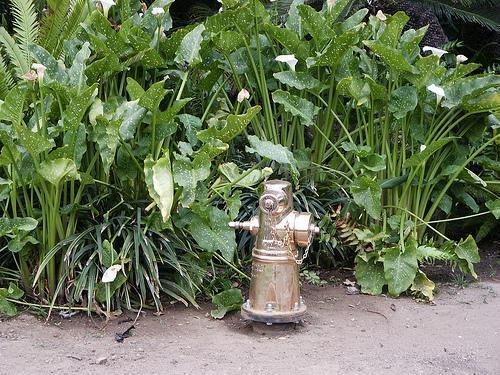How many fire hydrants are there?
Give a very brief answer. 1. 